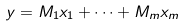Convert formula to latex. <formula><loc_0><loc_0><loc_500><loc_500>y = M _ { 1 } x _ { 1 } + \cdots + M _ { m } x _ { m }</formula> 